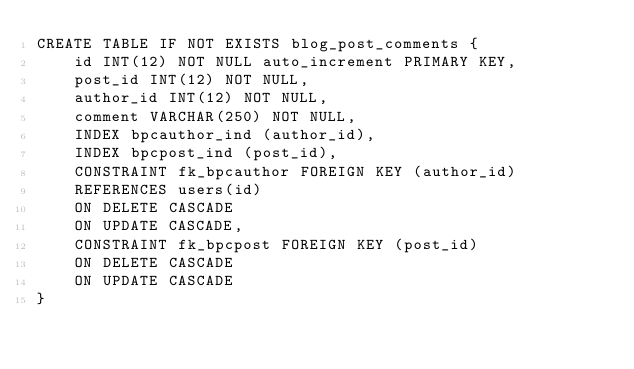Convert code to text. <code><loc_0><loc_0><loc_500><loc_500><_SQL_>CREATE TABLE IF NOT EXISTS blog_post_comments {
    id INT(12) NOT NULL auto_increment PRIMARY KEY,
    post_id INT(12) NOT NULL,
    author_id INT(12) NOT NULL,
    comment VARCHAR(250) NOT NULL,
    INDEX bpcauthor_ind (author_id),
    INDEX bpcpost_ind (post_id),
    CONSTRAINT fk_bpcauthor FOREIGN KEY (author_id)
    REFERENCES users(id)
    ON DELETE CASCADE
    ON UPDATE CASCADE,
    CONSTRAINT fk_bpcpost FOREIGN KEY (post_id)
    ON DELETE CASCADE
    ON UPDATE CASCADE
}</code> 